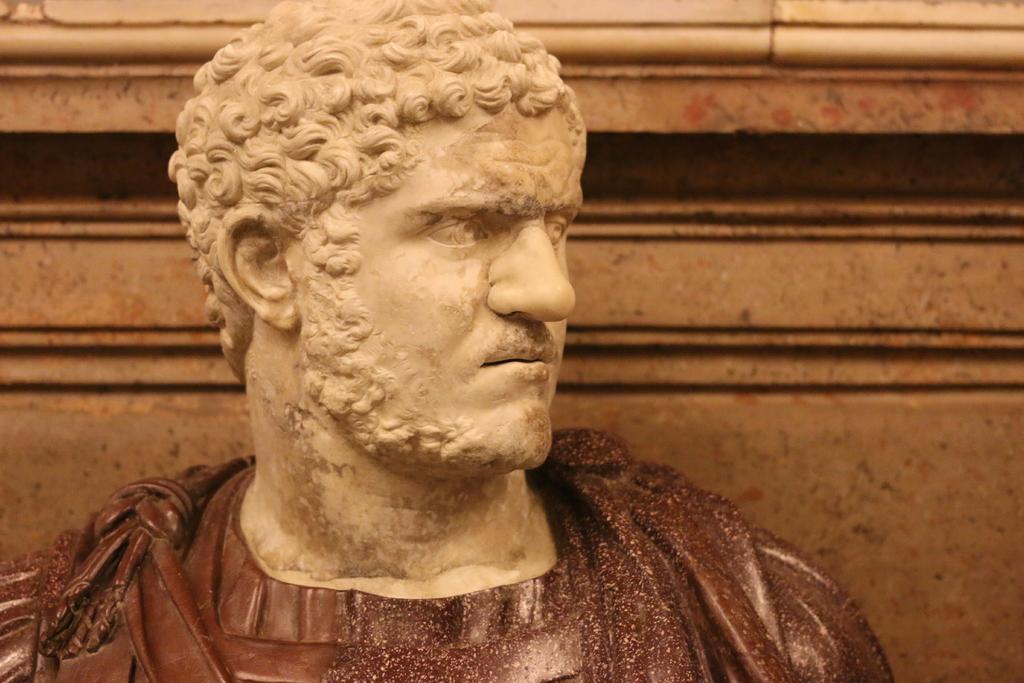Please provide a concise description of this image. There is a statue of a person. In the background, there is a wall. 